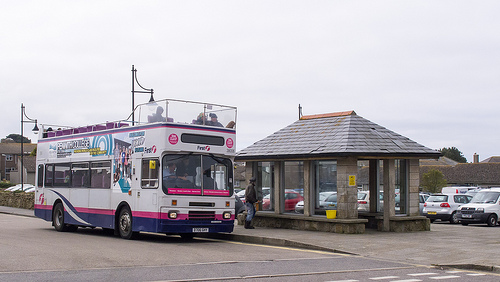Can you tell a story involving the bus in this image? Once upon a time, in a small coastal town, there was a unique double-decker bus known to everyone as 'Skybus'. It had been retired from city tours and had found a second life in this quaint town. Every morning, it would pick up children from different parts of the town and take them to school. The children loved the bus because it was the only one that sang. Yes, Skybus had a special feature: a built-in karaoke system. As it drove along the coastal roads, children would sing along, making their commute a daily joyride. On weekends, Skybus turned into an adventure ride for tourists visiting the town, offering karaoke tours along picturesque routes. It became a beloved symbol of happiness and musical fun. What if the bus had a secret mission? What could it be? What if Skybus had a secret mission? Each night, after dropping off the last passenger, it transformed into 'Agent Skybus', a vehicle part of a covert team working to protect the town. With gadgets disguised as regular bus features, it would sneak around town gathering intelligence on any suspicious activities. The bus shelter at the stop doubled as a command center where plans were developed. One night, it discovered a plot against the annual fair, and Agent Skybus, with its clever gadgets and team of undercover agents, thwarted the dastardly plan just in time. The townsfolk never knew the double life of their favorite bus, but they were always grateful for the mysterious sense of security they felt. 